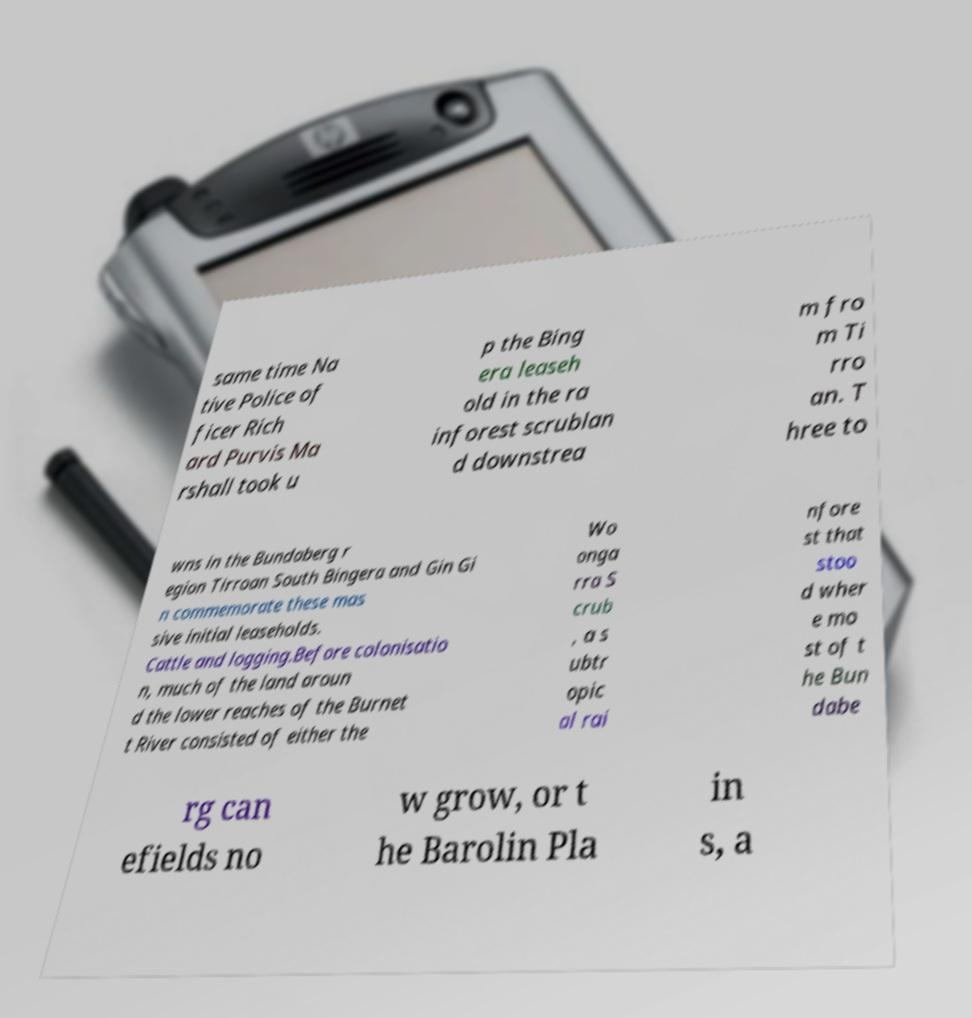For documentation purposes, I need the text within this image transcribed. Could you provide that? same time Na tive Police of ficer Rich ard Purvis Ma rshall took u p the Bing era leaseh old in the ra inforest scrublan d downstrea m fro m Ti rro an. T hree to wns in the Bundaberg r egion Tirroan South Bingera and Gin Gi n commemorate these mas sive initial leaseholds. Cattle and logging.Before colonisatio n, much of the land aroun d the lower reaches of the Burnet t River consisted of either the Wo onga rra S crub , a s ubtr opic al rai nfore st that stoo d wher e mo st of t he Bun dabe rg can efields no w grow, or t he Barolin Pla in s, a 